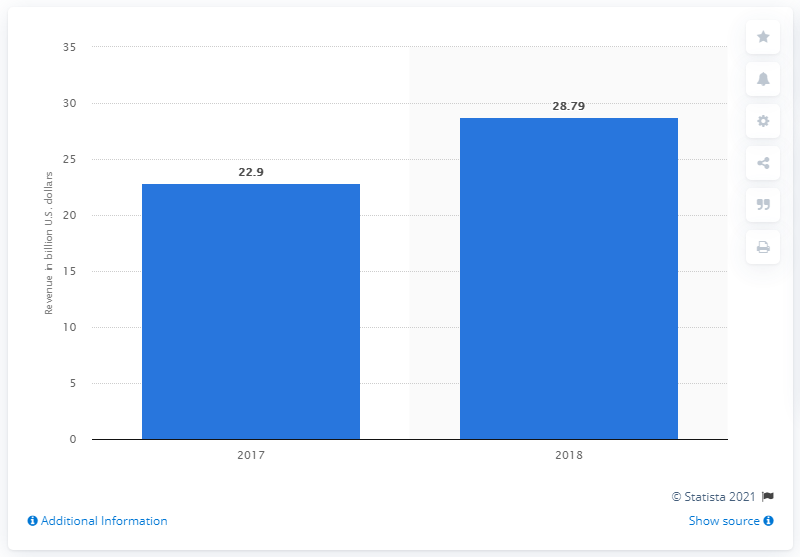Point out several critical features in this image. In 2017, the revenue was 22.9. In 2017, the revenue was 5.89, while in 2018 it increased to... In 2018, the total revenue for video and OTT television was 28.79. The total revenue for video and OTT television increased by 28.79% between 2017 and 2018. 